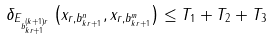Convert formula to latex. <formula><loc_0><loc_0><loc_500><loc_500>\delta _ { E _ { b _ { k r + 1 } ^ { ( k + 1 ) r } } } \left ( x _ { r , b _ { k r + 1 } ^ { n } } , x _ { r , b _ { k r + 1 } ^ { m } } \right ) \leq T _ { 1 } + T _ { 2 } + T _ { 3 }</formula> 